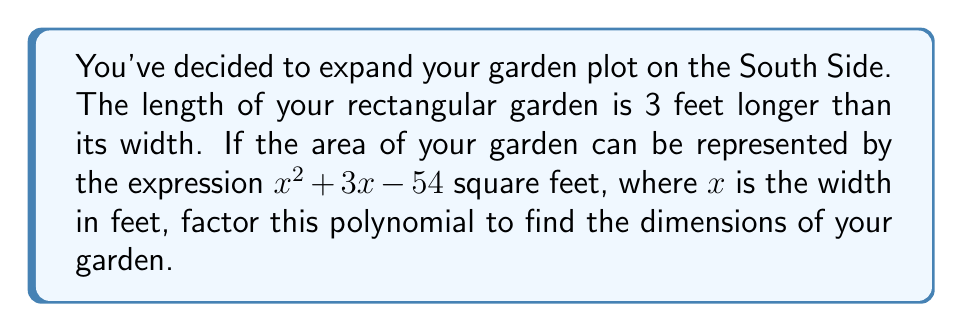Could you help me with this problem? Let's approach this step-by-step:

1) We're given the polynomial $x^2 + 3x - 54$, which represents the area of the garden.

2) We know that for a rectangle, Area = Length × Width

3) We're told that the length is 3 feet longer than the width. So if we let $x$ represent the width, then $(x+3)$ represents the length.

4) Therefore, we can write: $x(x+3) = x^2 + 3x - 54$

5) This confirms that our polynomial is indeed in the form of (Width)(Length).

6) To factor $x^2 + 3x - 54$, we need to find two numbers that multiply to give -54 and add to give 3.

7) These numbers are 9 and -6.

8) So we can rewrite our polynomial as: $x^2 + 9x - 6x - 54$

9) Grouping these terms: $(x^2 + 9x) + (-6x - 54)$

10) Factoring out common factors: $x(x + 9) - 6(x + 9)$

11) We can now factor out $(x + 9)$: $(x + 9)(x - 6)$

Therefore, the factored form is $(x + 9)(x - 6)$.

This means the width of the garden is $x = 6$ feet (the positive root), and the length is $x + 3 = 9$ feet.
Answer: The factored polynomial is $$(x + 9)(x - 6)$$
The dimensions of the garden are 6 feet wide and 9 feet long. 